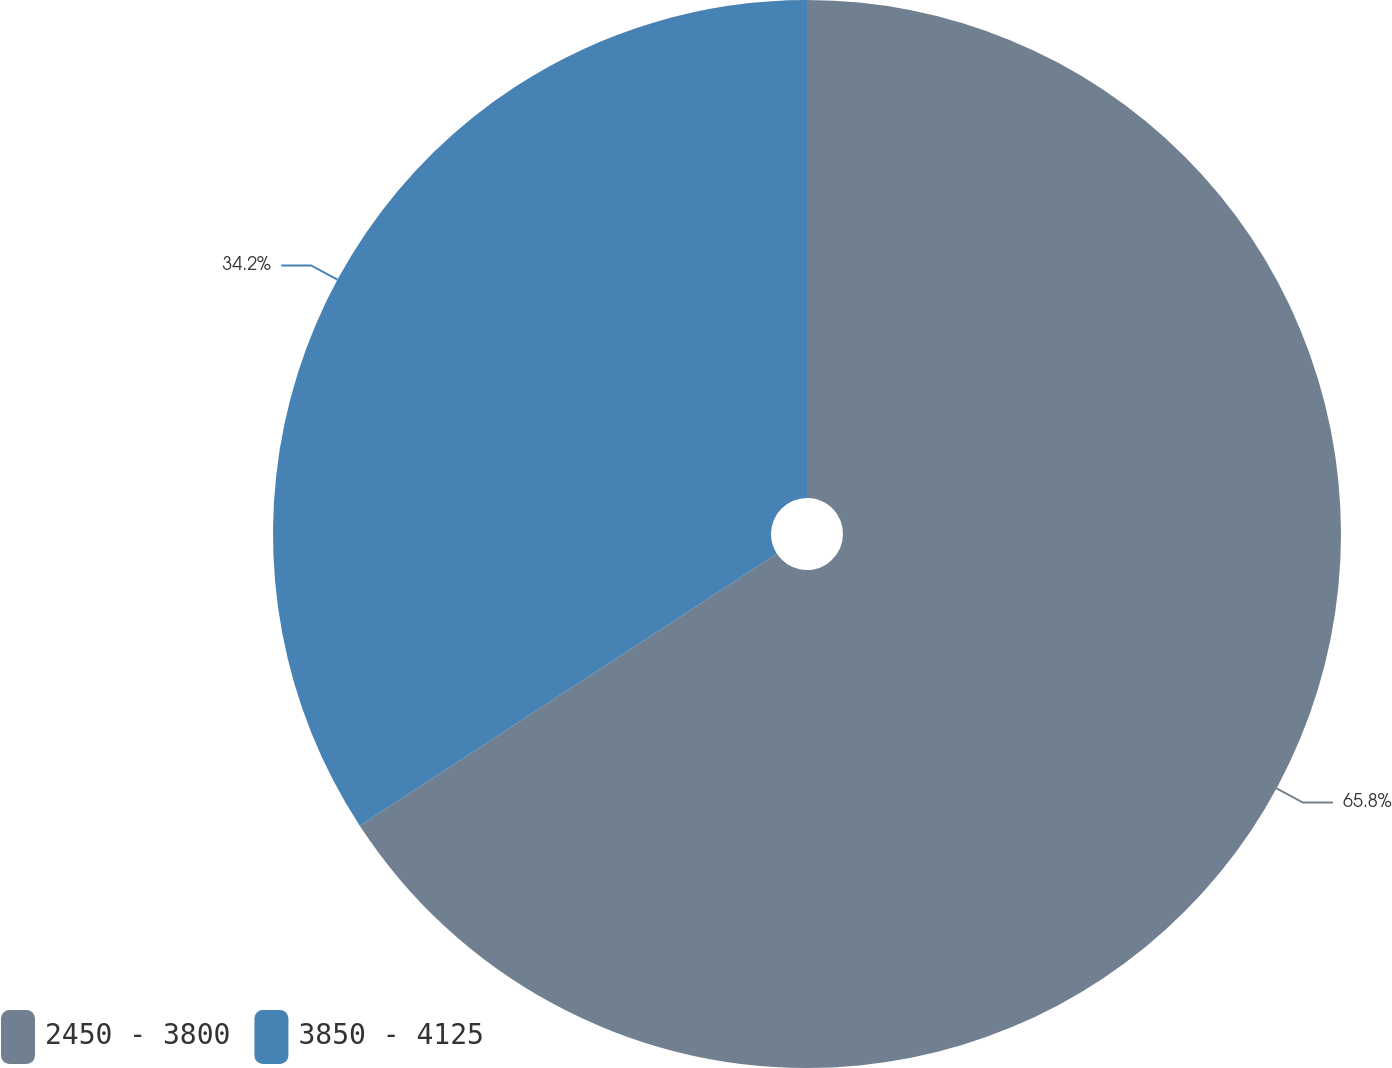<chart> <loc_0><loc_0><loc_500><loc_500><pie_chart><fcel>2450 - 3800<fcel>3850 - 4125<nl><fcel>65.8%<fcel>34.2%<nl></chart> 